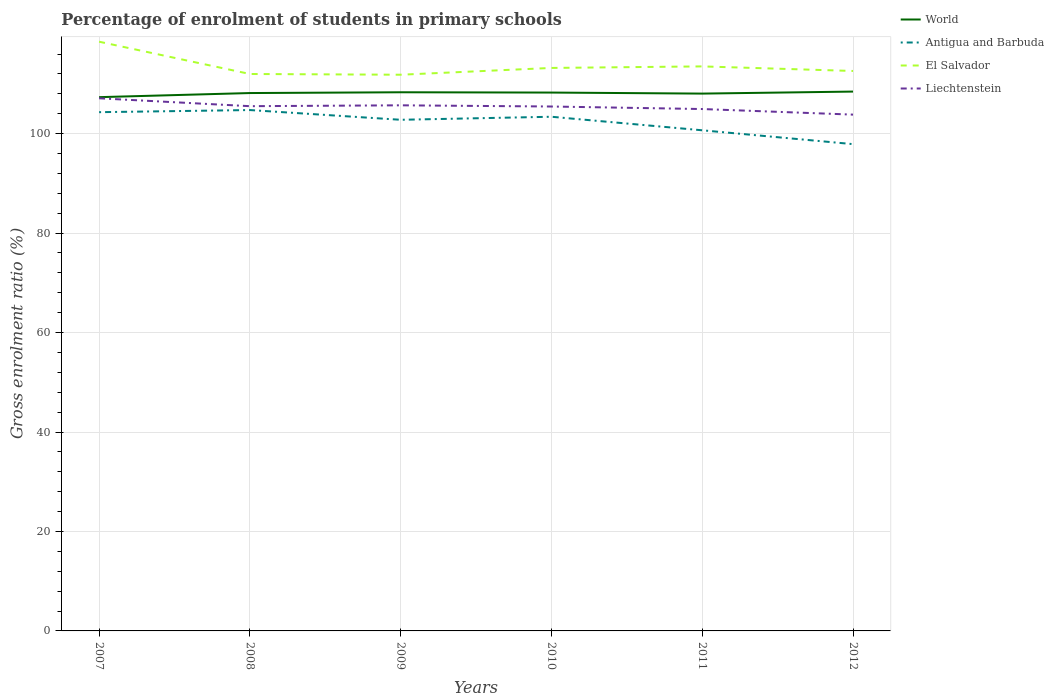Across all years, what is the maximum percentage of students enrolled in primary schools in El Salvador?
Your answer should be compact. 111.85. In which year was the percentage of students enrolled in primary schools in Antigua and Barbuda maximum?
Keep it short and to the point. 2012. What is the total percentage of students enrolled in primary schools in El Salvador in the graph?
Give a very brief answer. -1.37. What is the difference between the highest and the second highest percentage of students enrolled in primary schools in El Salvador?
Keep it short and to the point. 6.64. Is the percentage of students enrolled in primary schools in World strictly greater than the percentage of students enrolled in primary schools in El Salvador over the years?
Your response must be concise. Yes. How many lines are there?
Provide a succinct answer. 4. What is the difference between two consecutive major ticks on the Y-axis?
Your answer should be very brief. 20. Does the graph contain any zero values?
Give a very brief answer. No. Does the graph contain grids?
Offer a terse response. Yes. How are the legend labels stacked?
Provide a short and direct response. Vertical. What is the title of the graph?
Your answer should be very brief. Percentage of enrolment of students in primary schools. Does "North America" appear as one of the legend labels in the graph?
Make the answer very short. No. What is the label or title of the X-axis?
Provide a short and direct response. Years. What is the label or title of the Y-axis?
Give a very brief answer. Gross enrolment ratio (%). What is the Gross enrolment ratio (%) of World in 2007?
Make the answer very short. 107.34. What is the Gross enrolment ratio (%) in Antigua and Barbuda in 2007?
Give a very brief answer. 104.32. What is the Gross enrolment ratio (%) of El Salvador in 2007?
Offer a terse response. 118.49. What is the Gross enrolment ratio (%) of Liechtenstein in 2007?
Offer a very short reply. 107.11. What is the Gross enrolment ratio (%) in World in 2008?
Keep it short and to the point. 108.17. What is the Gross enrolment ratio (%) of Antigua and Barbuda in 2008?
Your answer should be very brief. 104.75. What is the Gross enrolment ratio (%) of El Salvador in 2008?
Provide a succinct answer. 112. What is the Gross enrolment ratio (%) of Liechtenstein in 2008?
Give a very brief answer. 105.53. What is the Gross enrolment ratio (%) in World in 2009?
Offer a terse response. 108.32. What is the Gross enrolment ratio (%) in Antigua and Barbuda in 2009?
Offer a terse response. 102.79. What is the Gross enrolment ratio (%) of El Salvador in 2009?
Ensure brevity in your answer.  111.85. What is the Gross enrolment ratio (%) in Liechtenstein in 2009?
Provide a succinct answer. 105.7. What is the Gross enrolment ratio (%) of World in 2010?
Offer a very short reply. 108.26. What is the Gross enrolment ratio (%) of Antigua and Barbuda in 2010?
Provide a short and direct response. 103.4. What is the Gross enrolment ratio (%) of El Salvador in 2010?
Keep it short and to the point. 113.22. What is the Gross enrolment ratio (%) in Liechtenstein in 2010?
Your answer should be compact. 105.46. What is the Gross enrolment ratio (%) of World in 2011?
Your answer should be very brief. 108.06. What is the Gross enrolment ratio (%) in Antigua and Barbuda in 2011?
Provide a succinct answer. 100.68. What is the Gross enrolment ratio (%) of El Salvador in 2011?
Give a very brief answer. 113.53. What is the Gross enrolment ratio (%) in Liechtenstein in 2011?
Offer a very short reply. 104.95. What is the Gross enrolment ratio (%) in World in 2012?
Keep it short and to the point. 108.46. What is the Gross enrolment ratio (%) in Antigua and Barbuda in 2012?
Ensure brevity in your answer.  97.89. What is the Gross enrolment ratio (%) of El Salvador in 2012?
Make the answer very short. 112.6. What is the Gross enrolment ratio (%) of Liechtenstein in 2012?
Make the answer very short. 103.83. Across all years, what is the maximum Gross enrolment ratio (%) of World?
Your response must be concise. 108.46. Across all years, what is the maximum Gross enrolment ratio (%) in Antigua and Barbuda?
Your response must be concise. 104.75. Across all years, what is the maximum Gross enrolment ratio (%) in El Salvador?
Give a very brief answer. 118.49. Across all years, what is the maximum Gross enrolment ratio (%) in Liechtenstein?
Make the answer very short. 107.11. Across all years, what is the minimum Gross enrolment ratio (%) in World?
Offer a terse response. 107.34. Across all years, what is the minimum Gross enrolment ratio (%) in Antigua and Barbuda?
Your response must be concise. 97.89. Across all years, what is the minimum Gross enrolment ratio (%) in El Salvador?
Your answer should be compact. 111.85. Across all years, what is the minimum Gross enrolment ratio (%) of Liechtenstein?
Give a very brief answer. 103.83. What is the total Gross enrolment ratio (%) in World in the graph?
Provide a short and direct response. 648.61. What is the total Gross enrolment ratio (%) of Antigua and Barbuda in the graph?
Your answer should be very brief. 613.83. What is the total Gross enrolment ratio (%) of El Salvador in the graph?
Offer a terse response. 681.69. What is the total Gross enrolment ratio (%) in Liechtenstein in the graph?
Offer a terse response. 632.57. What is the difference between the Gross enrolment ratio (%) of World in 2007 and that in 2008?
Offer a terse response. -0.83. What is the difference between the Gross enrolment ratio (%) in Antigua and Barbuda in 2007 and that in 2008?
Provide a succinct answer. -0.43. What is the difference between the Gross enrolment ratio (%) of El Salvador in 2007 and that in 2008?
Make the answer very short. 6.49. What is the difference between the Gross enrolment ratio (%) in Liechtenstein in 2007 and that in 2008?
Your answer should be very brief. 1.59. What is the difference between the Gross enrolment ratio (%) of World in 2007 and that in 2009?
Ensure brevity in your answer.  -0.98. What is the difference between the Gross enrolment ratio (%) in Antigua and Barbuda in 2007 and that in 2009?
Your answer should be compact. 1.53. What is the difference between the Gross enrolment ratio (%) of El Salvador in 2007 and that in 2009?
Provide a short and direct response. 6.64. What is the difference between the Gross enrolment ratio (%) in Liechtenstein in 2007 and that in 2009?
Your answer should be compact. 1.41. What is the difference between the Gross enrolment ratio (%) in World in 2007 and that in 2010?
Offer a terse response. -0.92. What is the difference between the Gross enrolment ratio (%) in Antigua and Barbuda in 2007 and that in 2010?
Offer a terse response. 0.92. What is the difference between the Gross enrolment ratio (%) of El Salvador in 2007 and that in 2010?
Offer a very short reply. 5.28. What is the difference between the Gross enrolment ratio (%) in Liechtenstein in 2007 and that in 2010?
Your answer should be compact. 1.65. What is the difference between the Gross enrolment ratio (%) of World in 2007 and that in 2011?
Provide a short and direct response. -0.72. What is the difference between the Gross enrolment ratio (%) in Antigua and Barbuda in 2007 and that in 2011?
Offer a terse response. 3.64. What is the difference between the Gross enrolment ratio (%) of El Salvador in 2007 and that in 2011?
Keep it short and to the point. 4.97. What is the difference between the Gross enrolment ratio (%) in Liechtenstein in 2007 and that in 2011?
Make the answer very short. 2.16. What is the difference between the Gross enrolment ratio (%) of World in 2007 and that in 2012?
Offer a terse response. -1.12. What is the difference between the Gross enrolment ratio (%) in Antigua and Barbuda in 2007 and that in 2012?
Your answer should be compact. 6.43. What is the difference between the Gross enrolment ratio (%) in El Salvador in 2007 and that in 2012?
Offer a terse response. 5.89. What is the difference between the Gross enrolment ratio (%) of Liechtenstein in 2007 and that in 2012?
Make the answer very short. 3.28. What is the difference between the Gross enrolment ratio (%) of World in 2008 and that in 2009?
Make the answer very short. -0.16. What is the difference between the Gross enrolment ratio (%) in Antigua and Barbuda in 2008 and that in 2009?
Make the answer very short. 1.96. What is the difference between the Gross enrolment ratio (%) of El Salvador in 2008 and that in 2009?
Your answer should be compact. 0.15. What is the difference between the Gross enrolment ratio (%) of Liechtenstein in 2008 and that in 2009?
Offer a terse response. -0.17. What is the difference between the Gross enrolment ratio (%) in World in 2008 and that in 2010?
Your answer should be compact. -0.1. What is the difference between the Gross enrolment ratio (%) in Antigua and Barbuda in 2008 and that in 2010?
Offer a very short reply. 1.35. What is the difference between the Gross enrolment ratio (%) in El Salvador in 2008 and that in 2010?
Your answer should be compact. -1.22. What is the difference between the Gross enrolment ratio (%) in Liechtenstein in 2008 and that in 2010?
Give a very brief answer. 0.07. What is the difference between the Gross enrolment ratio (%) of World in 2008 and that in 2011?
Your answer should be very brief. 0.11. What is the difference between the Gross enrolment ratio (%) in Antigua and Barbuda in 2008 and that in 2011?
Keep it short and to the point. 4.07. What is the difference between the Gross enrolment ratio (%) of El Salvador in 2008 and that in 2011?
Provide a succinct answer. -1.53. What is the difference between the Gross enrolment ratio (%) in Liechtenstein in 2008 and that in 2011?
Your answer should be compact. 0.58. What is the difference between the Gross enrolment ratio (%) of World in 2008 and that in 2012?
Your answer should be very brief. -0.29. What is the difference between the Gross enrolment ratio (%) of Antigua and Barbuda in 2008 and that in 2012?
Give a very brief answer. 6.85. What is the difference between the Gross enrolment ratio (%) in El Salvador in 2008 and that in 2012?
Provide a succinct answer. -0.61. What is the difference between the Gross enrolment ratio (%) of Liechtenstein in 2008 and that in 2012?
Ensure brevity in your answer.  1.7. What is the difference between the Gross enrolment ratio (%) in World in 2009 and that in 2010?
Keep it short and to the point. 0.06. What is the difference between the Gross enrolment ratio (%) of Antigua and Barbuda in 2009 and that in 2010?
Provide a short and direct response. -0.61. What is the difference between the Gross enrolment ratio (%) of El Salvador in 2009 and that in 2010?
Your answer should be compact. -1.37. What is the difference between the Gross enrolment ratio (%) in Liechtenstein in 2009 and that in 2010?
Ensure brevity in your answer.  0.24. What is the difference between the Gross enrolment ratio (%) in World in 2009 and that in 2011?
Your answer should be very brief. 0.27. What is the difference between the Gross enrolment ratio (%) of Antigua and Barbuda in 2009 and that in 2011?
Keep it short and to the point. 2.11. What is the difference between the Gross enrolment ratio (%) in El Salvador in 2009 and that in 2011?
Provide a succinct answer. -1.67. What is the difference between the Gross enrolment ratio (%) of Liechtenstein in 2009 and that in 2011?
Give a very brief answer. 0.75. What is the difference between the Gross enrolment ratio (%) of World in 2009 and that in 2012?
Provide a succinct answer. -0.14. What is the difference between the Gross enrolment ratio (%) in Antigua and Barbuda in 2009 and that in 2012?
Your response must be concise. 4.9. What is the difference between the Gross enrolment ratio (%) of El Salvador in 2009 and that in 2012?
Give a very brief answer. -0.75. What is the difference between the Gross enrolment ratio (%) in Liechtenstein in 2009 and that in 2012?
Offer a very short reply. 1.87. What is the difference between the Gross enrolment ratio (%) of World in 2010 and that in 2011?
Provide a short and direct response. 0.21. What is the difference between the Gross enrolment ratio (%) in Antigua and Barbuda in 2010 and that in 2011?
Keep it short and to the point. 2.72. What is the difference between the Gross enrolment ratio (%) of El Salvador in 2010 and that in 2011?
Offer a very short reply. -0.31. What is the difference between the Gross enrolment ratio (%) in Liechtenstein in 2010 and that in 2011?
Offer a very short reply. 0.51. What is the difference between the Gross enrolment ratio (%) in World in 2010 and that in 2012?
Ensure brevity in your answer.  -0.2. What is the difference between the Gross enrolment ratio (%) in Antigua and Barbuda in 2010 and that in 2012?
Give a very brief answer. 5.51. What is the difference between the Gross enrolment ratio (%) of El Salvador in 2010 and that in 2012?
Offer a terse response. 0.61. What is the difference between the Gross enrolment ratio (%) in Liechtenstein in 2010 and that in 2012?
Provide a succinct answer. 1.63. What is the difference between the Gross enrolment ratio (%) in World in 2011 and that in 2012?
Provide a short and direct response. -0.4. What is the difference between the Gross enrolment ratio (%) of Antigua and Barbuda in 2011 and that in 2012?
Provide a succinct answer. 2.78. What is the difference between the Gross enrolment ratio (%) of El Salvador in 2011 and that in 2012?
Offer a terse response. 0.92. What is the difference between the Gross enrolment ratio (%) in Liechtenstein in 2011 and that in 2012?
Provide a succinct answer. 1.12. What is the difference between the Gross enrolment ratio (%) in World in 2007 and the Gross enrolment ratio (%) in Antigua and Barbuda in 2008?
Your response must be concise. 2.59. What is the difference between the Gross enrolment ratio (%) in World in 2007 and the Gross enrolment ratio (%) in El Salvador in 2008?
Give a very brief answer. -4.66. What is the difference between the Gross enrolment ratio (%) in World in 2007 and the Gross enrolment ratio (%) in Liechtenstein in 2008?
Provide a short and direct response. 1.81. What is the difference between the Gross enrolment ratio (%) of Antigua and Barbuda in 2007 and the Gross enrolment ratio (%) of El Salvador in 2008?
Make the answer very short. -7.68. What is the difference between the Gross enrolment ratio (%) in Antigua and Barbuda in 2007 and the Gross enrolment ratio (%) in Liechtenstein in 2008?
Ensure brevity in your answer.  -1.21. What is the difference between the Gross enrolment ratio (%) of El Salvador in 2007 and the Gross enrolment ratio (%) of Liechtenstein in 2008?
Your answer should be very brief. 12.97. What is the difference between the Gross enrolment ratio (%) in World in 2007 and the Gross enrolment ratio (%) in Antigua and Barbuda in 2009?
Make the answer very short. 4.55. What is the difference between the Gross enrolment ratio (%) in World in 2007 and the Gross enrolment ratio (%) in El Salvador in 2009?
Ensure brevity in your answer.  -4.51. What is the difference between the Gross enrolment ratio (%) of World in 2007 and the Gross enrolment ratio (%) of Liechtenstein in 2009?
Provide a succinct answer. 1.64. What is the difference between the Gross enrolment ratio (%) in Antigua and Barbuda in 2007 and the Gross enrolment ratio (%) in El Salvador in 2009?
Your answer should be very brief. -7.53. What is the difference between the Gross enrolment ratio (%) in Antigua and Barbuda in 2007 and the Gross enrolment ratio (%) in Liechtenstein in 2009?
Provide a succinct answer. -1.38. What is the difference between the Gross enrolment ratio (%) of El Salvador in 2007 and the Gross enrolment ratio (%) of Liechtenstein in 2009?
Your answer should be very brief. 12.79. What is the difference between the Gross enrolment ratio (%) of World in 2007 and the Gross enrolment ratio (%) of Antigua and Barbuda in 2010?
Give a very brief answer. 3.94. What is the difference between the Gross enrolment ratio (%) in World in 2007 and the Gross enrolment ratio (%) in El Salvador in 2010?
Your answer should be very brief. -5.88. What is the difference between the Gross enrolment ratio (%) in World in 2007 and the Gross enrolment ratio (%) in Liechtenstein in 2010?
Offer a very short reply. 1.88. What is the difference between the Gross enrolment ratio (%) in Antigua and Barbuda in 2007 and the Gross enrolment ratio (%) in El Salvador in 2010?
Ensure brevity in your answer.  -8.9. What is the difference between the Gross enrolment ratio (%) of Antigua and Barbuda in 2007 and the Gross enrolment ratio (%) of Liechtenstein in 2010?
Your response must be concise. -1.14. What is the difference between the Gross enrolment ratio (%) of El Salvador in 2007 and the Gross enrolment ratio (%) of Liechtenstein in 2010?
Keep it short and to the point. 13.03. What is the difference between the Gross enrolment ratio (%) in World in 2007 and the Gross enrolment ratio (%) in Antigua and Barbuda in 2011?
Your response must be concise. 6.66. What is the difference between the Gross enrolment ratio (%) of World in 2007 and the Gross enrolment ratio (%) of El Salvador in 2011?
Provide a short and direct response. -6.19. What is the difference between the Gross enrolment ratio (%) of World in 2007 and the Gross enrolment ratio (%) of Liechtenstein in 2011?
Your response must be concise. 2.39. What is the difference between the Gross enrolment ratio (%) in Antigua and Barbuda in 2007 and the Gross enrolment ratio (%) in El Salvador in 2011?
Ensure brevity in your answer.  -9.21. What is the difference between the Gross enrolment ratio (%) of Antigua and Barbuda in 2007 and the Gross enrolment ratio (%) of Liechtenstein in 2011?
Your response must be concise. -0.63. What is the difference between the Gross enrolment ratio (%) in El Salvador in 2007 and the Gross enrolment ratio (%) in Liechtenstein in 2011?
Ensure brevity in your answer.  13.54. What is the difference between the Gross enrolment ratio (%) of World in 2007 and the Gross enrolment ratio (%) of Antigua and Barbuda in 2012?
Your answer should be very brief. 9.45. What is the difference between the Gross enrolment ratio (%) of World in 2007 and the Gross enrolment ratio (%) of El Salvador in 2012?
Make the answer very short. -5.26. What is the difference between the Gross enrolment ratio (%) in World in 2007 and the Gross enrolment ratio (%) in Liechtenstein in 2012?
Your answer should be compact. 3.51. What is the difference between the Gross enrolment ratio (%) of Antigua and Barbuda in 2007 and the Gross enrolment ratio (%) of El Salvador in 2012?
Provide a succinct answer. -8.29. What is the difference between the Gross enrolment ratio (%) of Antigua and Barbuda in 2007 and the Gross enrolment ratio (%) of Liechtenstein in 2012?
Keep it short and to the point. 0.49. What is the difference between the Gross enrolment ratio (%) of El Salvador in 2007 and the Gross enrolment ratio (%) of Liechtenstein in 2012?
Make the answer very short. 14.66. What is the difference between the Gross enrolment ratio (%) in World in 2008 and the Gross enrolment ratio (%) in Antigua and Barbuda in 2009?
Keep it short and to the point. 5.38. What is the difference between the Gross enrolment ratio (%) of World in 2008 and the Gross enrolment ratio (%) of El Salvador in 2009?
Your response must be concise. -3.68. What is the difference between the Gross enrolment ratio (%) of World in 2008 and the Gross enrolment ratio (%) of Liechtenstein in 2009?
Your response must be concise. 2.47. What is the difference between the Gross enrolment ratio (%) of Antigua and Barbuda in 2008 and the Gross enrolment ratio (%) of El Salvador in 2009?
Your response must be concise. -7.1. What is the difference between the Gross enrolment ratio (%) of Antigua and Barbuda in 2008 and the Gross enrolment ratio (%) of Liechtenstein in 2009?
Your answer should be compact. -0.95. What is the difference between the Gross enrolment ratio (%) of El Salvador in 2008 and the Gross enrolment ratio (%) of Liechtenstein in 2009?
Your answer should be very brief. 6.3. What is the difference between the Gross enrolment ratio (%) in World in 2008 and the Gross enrolment ratio (%) in Antigua and Barbuda in 2010?
Provide a short and direct response. 4.77. What is the difference between the Gross enrolment ratio (%) in World in 2008 and the Gross enrolment ratio (%) in El Salvador in 2010?
Your answer should be compact. -5.05. What is the difference between the Gross enrolment ratio (%) in World in 2008 and the Gross enrolment ratio (%) in Liechtenstein in 2010?
Your answer should be very brief. 2.71. What is the difference between the Gross enrolment ratio (%) of Antigua and Barbuda in 2008 and the Gross enrolment ratio (%) of El Salvador in 2010?
Your response must be concise. -8.47. What is the difference between the Gross enrolment ratio (%) in Antigua and Barbuda in 2008 and the Gross enrolment ratio (%) in Liechtenstein in 2010?
Offer a terse response. -0.71. What is the difference between the Gross enrolment ratio (%) in El Salvador in 2008 and the Gross enrolment ratio (%) in Liechtenstein in 2010?
Your answer should be compact. 6.54. What is the difference between the Gross enrolment ratio (%) of World in 2008 and the Gross enrolment ratio (%) of Antigua and Barbuda in 2011?
Give a very brief answer. 7.49. What is the difference between the Gross enrolment ratio (%) of World in 2008 and the Gross enrolment ratio (%) of El Salvador in 2011?
Your response must be concise. -5.36. What is the difference between the Gross enrolment ratio (%) of World in 2008 and the Gross enrolment ratio (%) of Liechtenstein in 2011?
Provide a succinct answer. 3.22. What is the difference between the Gross enrolment ratio (%) in Antigua and Barbuda in 2008 and the Gross enrolment ratio (%) in El Salvador in 2011?
Offer a terse response. -8.78. What is the difference between the Gross enrolment ratio (%) in Antigua and Barbuda in 2008 and the Gross enrolment ratio (%) in Liechtenstein in 2011?
Provide a succinct answer. -0.2. What is the difference between the Gross enrolment ratio (%) of El Salvador in 2008 and the Gross enrolment ratio (%) of Liechtenstein in 2011?
Provide a short and direct response. 7.05. What is the difference between the Gross enrolment ratio (%) of World in 2008 and the Gross enrolment ratio (%) of Antigua and Barbuda in 2012?
Offer a very short reply. 10.27. What is the difference between the Gross enrolment ratio (%) of World in 2008 and the Gross enrolment ratio (%) of El Salvador in 2012?
Offer a very short reply. -4.44. What is the difference between the Gross enrolment ratio (%) in World in 2008 and the Gross enrolment ratio (%) in Liechtenstein in 2012?
Offer a very short reply. 4.34. What is the difference between the Gross enrolment ratio (%) in Antigua and Barbuda in 2008 and the Gross enrolment ratio (%) in El Salvador in 2012?
Offer a terse response. -7.86. What is the difference between the Gross enrolment ratio (%) of Antigua and Barbuda in 2008 and the Gross enrolment ratio (%) of Liechtenstein in 2012?
Offer a very short reply. 0.92. What is the difference between the Gross enrolment ratio (%) of El Salvador in 2008 and the Gross enrolment ratio (%) of Liechtenstein in 2012?
Make the answer very short. 8.17. What is the difference between the Gross enrolment ratio (%) of World in 2009 and the Gross enrolment ratio (%) of Antigua and Barbuda in 2010?
Make the answer very short. 4.92. What is the difference between the Gross enrolment ratio (%) of World in 2009 and the Gross enrolment ratio (%) of El Salvador in 2010?
Make the answer very short. -4.89. What is the difference between the Gross enrolment ratio (%) in World in 2009 and the Gross enrolment ratio (%) in Liechtenstein in 2010?
Provide a succinct answer. 2.86. What is the difference between the Gross enrolment ratio (%) in Antigua and Barbuda in 2009 and the Gross enrolment ratio (%) in El Salvador in 2010?
Provide a succinct answer. -10.43. What is the difference between the Gross enrolment ratio (%) of Antigua and Barbuda in 2009 and the Gross enrolment ratio (%) of Liechtenstein in 2010?
Provide a short and direct response. -2.67. What is the difference between the Gross enrolment ratio (%) of El Salvador in 2009 and the Gross enrolment ratio (%) of Liechtenstein in 2010?
Ensure brevity in your answer.  6.39. What is the difference between the Gross enrolment ratio (%) in World in 2009 and the Gross enrolment ratio (%) in Antigua and Barbuda in 2011?
Provide a short and direct response. 7.65. What is the difference between the Gross enrolment ratio (%) of World in 2009 and the Gross enrolment ratio (%) of El Salvador in 2011?
Your answer should be compact. -5.2. What is the difference between the Gross enrolment ratio (%) in World in 2009 and the Gross enrolment ratio (%) in Liechtenstein in 2011?
Your response must be concise. 3.37. What is the difference between the Gross enrolment ratio (%) of Antigua and Barbuda in 2009 and the Gross enrolment ratio (%) of El Salvador in 2011?
Make the answer very short. -10.74. What is the difference between the Gross enrolment ratio (%) in Antigua and Barbuda in 2009 and the Gross enrolment ratio (%) in Liechtenstein in 2011?
Ensure brevity in your answer.  -2.16. What is the difference between the Gross enrolment ratio (%) in El Salvador in 2009 and the Gross enrolment ratio (%) in Liechtenstein in 2011?
Keep it short and to the point. 6.9. What is the difference between the Gross enrolment ratio (%) in World in 2009 and the Gross enrolment ratio (%) in Antigua and Barbuda in 2012?
Offer a terse response. 10.43. What is the difference between the Gross enrolment ratio (%) in World in 2009 and the Gross enrolment ratio (%) in El Salvador in 2012?
Provide a succinct answer. -4.28. What is the difference between the Gross enrolment ratio (%) in World in 2009 and the Gross enrolment ratio (%) in Liechtenstein in 2012?
Offer a terse response. 4.5. What is the difference between the Gross enrolment ratio (%) of Antigua and Barbuda in 2009 and the Gross enrolment ratio (%) of El Salvador in 2012?
Make the answer very short. -9.82. What is the difference between the Gross enrolment ratio (%) of Antigua and Barbuda in 2009 and the Gross enrolment ratio (%) of Liechtenstein in 2012?
Provide a succinct answer. -1.04. What is the difference between the Gross enrolment ratio (%) in El Salvador in 2009 and the Gross enrolment ratio (%) in Liechtenstein in 2012?
Make the answer very short. 8.02. What is the difference between the Gross enrolment ratio (%) in World in 2010 and the Gross enrolment ratio (%) in Antigua and Barbuda in 2011?
Your response must be concise. 7.59. What is the difference between the Gross enrolment ratio (%) in World in 2010 and the Gross enrolment ratio (%) in El Salvador in 2011?
Provide a succinct answer. -5.26. What is the difference between the Gross enrolment ratio (%) of World in 2010 and the Gross enrolment ratio (%) of Liechtenstein in 2011?
Give a very brief answer. 3.31. What is the difference between the Gross enrolment ratio (%) in Antigua and Barbuda in 2010 and the Gross enrolment ratio (%) in El Salvador in 2011?
Ensure brevity in your answer.  -10.13. What is the difference between the Gross enrolment ratio (%) of Antigua and Barbuda in 2010 and the Gross enrolment ratio (%) of Liechtenstein in 2011?
Offer a terse response. -1.55. What is the difference between the Gross enrolment ratio (%) of El Salvador in 2010 and the Gross enrolment ratio (%) of Liechtenstein in 2011?
Keep it short and to the point. 8.27. What is the difference between the Gross enrolment ratio (%) in World in 2010 and the Gross enrolment ratio (%) in Antigua and Barbuda in 2012?
Keep it short and to the point. 10.37. What is the difference between the Gross enrolment ratio (%) in World in 2010 and the Gross enrolment ratio (%) in El Salvador in 2012?
Provide a short and direct response. -4.34. What is the difference between the Gross enrolment ratio (%) in World in 2010 and the Gross enrolment ratio (%) in Liechtenstein in 2012?
Your answer should be compact. 4.44. What is the difference between the Gross enrolment ratio (%) of Antigua and Barbuda in 2010 and the Gross enrolment ratio (%) of El Salvador in 2012?
Offer a terse response. -9.21. What is the difference between the Gross enrolment ratio (%) of Antigua and Barbuda in 2010 and the Gross enrolment ratio (%) of Liechtenstein in 2012?
Provide a short and direct response. -0.43. What is the difference between the Gross enrolment ratio (%) in El Salvador in 2010 and the Gross enrolment ratio (%) in Liechtenstein in 2012?
Provide a succinct answer. 9.39. What is the difference between the Gross enrolment ratio (%) of World in 2011 and the Gross enrolment ratio (%) of Antigua and Barbuda in 2012?
Your response must be concise. 10.16. What is the difference between the Gross enrolment ratio (%) in World in 2011 and the Gross enrolment ratio (%) in El Salvador in 2012?
Keep it short and to the point. -4.55. What is the difference between the Gross enrolment ratio (%) of World in 2011 and the Gross enrolment ratio (%) of Liechtenstein in 2012?
Your answer should be very brief. 4.23. What is the difference between the Gross enrolment ratio (%) in Antigua and Barbuda in 2011 and the Gross enrolment ratio (%) in El Salvador in 2012?
Provide a succinct answer. -11.93. What is the difference between the Gross enrolment ratio (%) in Antigua and Barbuda in 2011 and the Gross enrolment ratio (%) in Liechtenstein in 2012?
Your answer should be very brief. -3.15. What is the difference between the Gross enrolment ratio (%) of El Salvador in 2011 and the Gross enrolment ratio (%) of Liechtenstein in 2012?
Provide a succinct answer. 9.7. What is the average Gross enrolment ratio (%) in World per year?
Your response must be concise. 108.1. What is the average Gross enrolment ratio (%) in Antigua and Barbuda per year?
Your answer should be very brief. 102.3. What is the average Gross enrolment ratio (%) of El Salvador per year?
Give a very brief answer. 113.62. What is the average Gross enrolment ratio (%) of Liechtenstein per year?
Keep it short and to the point. 105.43. In the year 2007, what is the difference between the Gross enrolment ratio (%) of World and Gross enrolment ratio (%) of Antigua and Barbuda?
Keep it short and to the point. 3.02. In the year 2007, what is the difference between the Gross enrolment ratio (%) in World and Gross enrolment ratio (%) in El Salvador?
Provide a succinct answer. -11.15. In the year 2007, what is the difference between the Gross enrolment ratio (%) of World and Gross enrolment ratio (%) of Liechtenstein?
Provide a short and direct response. 0.23. In the year 2007, what is the difference between the Gross enrolment ratio (%) in Antigua and Barbuda and Gross enrolment ratio (%) in El Salvador?
Your answer should be compact. -14.17. In the year 2007, what is the difference between the Gross enrolment ratio (%) in Antigua and Barbuda and Gross enrolment ratio (%) in Liechtenstein?
Your answer should be very brief. -2.79. In the year 2007, what is the difference between the Gross enrolment ratio (%) in El Salvador and Gross enrolment ratio (%) in Liechtenstein?
Keep it short and to the point. 11.38. In the year 2008, what is the difference between the Gross enrolment ratio (%) of World and Gross enrolment ratio (%) of Antigua and Barbuda?
Ensure brevity in your answer.  3.42. In the year 2008, what is the difference between the Gross enrolment ratio (%) of World and Gross enrolment ratio (%) of El Salvador?
Offer a terse response. -3.83. In the year 2008, what is the difference between the Gross enrolment ratio (%) in World and Gross enrolment ratio (%) in Liechtenstein?
Make the answer very short. 2.64. In the year 2008, what is the difference between the Gross enrolment ratio (%) of Antigua and Barbuda and Gross enrolment ratio (%) of El Salvador?
Ensure brevity in your answer.  -7.25. In the year 2008, what is the difference between the Gross enrolment ratio (%) of Antigua and Barbuda and Gross enrolment ratio (%) of Liechtenstein?
Ensure brevity in your answer.  -0.78. In the year 2008, what is the difference between the Gross enrolment ratio (%) of El Salvador and Gross enrolment ratio (%) of Liechtenstein?
Offer a terse response. 6.47. In the year 2009, what is the difference between the Gross enrolment ratio (%) of World and Gross enrolment ratio (%) of Antigua and Barbuda?
Offer a very short reply. 5.53. In the year 2009, what is the difference between the Gross enrolment ratio (%) in World and Gross enrolment ratio (%) in El Salvador?
Provide a succinct answer. -3.53. In the year 2009, what is the difference between the Gross enrolment ratio (%) in World and Gross enrolment ratio (%) in Liechtenstein?
Your answer should be very brief. 2.63. In the year 2009, what is the difference between the Gross enrolment ratio (%) in Antigua and Barbuda and Gross enrolment ratio (%) in El Salvador?
Your answer should be very brief. -9.06. In the year 2009, what is the difference between the Gross enrolment ratio (%) of Antigua and Barbuda and Gross enrolment ratio (%) of Liechtenstein?
Give a very brief answer. -2.91. In the year 2009, what is the difference between the Gross enrolment ratio (%) in El Salvador and Gross enrolment ratio (%) in Liechtenstein?
Provide a succinct answer. 6.15. In the year 2010, what is the difference between the Gross enrolment ratio (%) of World and Gross enrolment ratio (%) of Antigua and Barbuda?
Your response must be concise. 4.86. In the year 2010, what is the difference between the Gross enrolment ratio (%) in World and Gross enrolment ratio (%) in El Salvador?
Make the answer very short. -4.95. In the year 2010, what is the difference between the Gross enrolment ratio (%) of World and Gross enrolment ratio (%) of Liechtenstein?
Ensure brevity in your answer.  2.81. In the year 2010, what is the difference between the Gross enrolment ratio (%) of Antigua and Barbuda and Gross enrolment ratio (%) of El Salvador?
Provide a short and direct response. -9.82. In the year 2010, what is the difference between the Gross enrolment ratio (%) in Antigua and Barbuda and Gross enrolment ratio (%) in Liechtenstein?
Provide a succinct answer. -2.06. In the year 2010, what is the difference between the Gross enrolment ratio (%) of El Salvador and Gross enrolment ratio (%) of Liechtenstein?
Your answer should be compact. 7.76. In the year 2011, what is the difference between the Gross enrolment ratio (%) in World and Gross enrolment ratio (%) in Antigua and Barbuda?
Provide a short and direct response. 7.38. In the year 2011, what is the difference between the Gross enrolment ratio (%) of World and Gross enrolment ratio (%) of El Salvador?
Make the answer very short. -5.47. In the year 2011, what is the difference between the Gross enrolment ratio (%) of World and Gross enrolment ratio (%) of Liechtenstein?
Keep it short and to the point. 3.11. In the year 2011, what is the difference between the Gross enrolment ratio (%) in Antigua and Barbuda and Gross enrolment ratio (%) in El Salvador?
Keep it short and to the point. -12.85. In the year 2011, what is the difference between the Gross enrolment ratio (%) in Antigua and Barbuda and Gross enrolment ratio (%) in Liechtenstein?
Your answer should be compact. -4.27. In the year 2011, what is the difference between the Gross enrolment ratio (%) in El Salvador and Gross enrolment ratio (%) in Liechtenstein?
Provide a short and direct response. 8.58. In the year 2012, what is the difference between the Gross enrolment ratio (%) of World and Gross enrolment ratio (%) of Antigua and Barbuda?
Provide a short and direct response. 10.57. In the year 2012, what is the difference between the Gross enrolment ratio (%) of World and Gross enrolment ratio (%) of El Salvador?
Your answer should be compact. -4.14. In the year 2012, what is the difference between the Gross enrolment ratio (%) of World and Gross enrolment ratio (%) of Liechtenstein?
Keep it short and to the point. 4.63. In the year 2012, what is the difference between the Gross enrolment ratio (%) in Antigua and Barbuda and Gross enrolment ratio (%) in El Salvador?
Offer a very short reply. -14.71. In the year 2012, what is the difference between the Gross enrolment ratio (%) of Antigua and Barbuda and Gross enrolment ratio (%) of Liechtenstein?
Give a very brief answer. -5.94. In the year 2012, what is the difference between the Gross enrolment ratio (%) in El Salvador and Gross enrolment ratio (%) in Liechtenstein?
Keep it short and to the point. 8.78. What is the ratio of the Gross enrolment ratio (%) of World in 2007 to that in 2008?
Offer a very short reply. 0.99. What is the ratio of the Gross enrolment ratio (%) of El Salvador in 2007 to that in 2008?
Provide a succinct answer. 1.06. What is the ratio of the Gross enrolment ratio (%) in World in 2007 to that in 2009?
Ensure brevity in your answer.  0.99. What is the ratio of the Gross enrolment ratio (%) of Antigua and Barbuda in 2007 to that in 2009?
Provide a succinct answer. 1.01. What is the ratio of the Gross enrolment ratio (%) of El Salvador in 2007 to that in 2009?
Provide a succinct answer. 1.06. What is the ratio of the Gross enrolment ratio (%) in Liechtenstein in 2007 to that in 2009?
Your answer should be very brief. 1.01. What is the ratio of the Gross enrolment ratio (%) in World in 2007 to that in 2010?
Make the answer very short. 0.99. What is the ratio of the Gross enrolment ratio (%) in Antigua and Barbuda in 2007 to that in 2010?
Provide a short and direct response. 1.01. What is the ratio of the Gross enrolment ratio (%) of El Salvador in 2007 to that in 2010?
Your answer should be compact. 1.05. What is the ratio of the Gross enrolment ratio (%) in Liechtenstein in 2007 to that in 2010?
Your answer should be very brief. 1.02. What is the ratio of the Gross enrolment ratio (%) in World in 2007 to that in 2011?
Keep it short and to the point. 0.99. What is the ratio of the Gross enrolment ratio (%) in Antigua and Barbuda in 2007 to that in 2011?
Provide a succinct answer. 1.04. What is the ratio of the Gross enrolment ratio (%) in El Salvador in 2007 to that in 2011?
Your answer should be compact. 1.04. What is the ratio of the Gross enrolment ratio (%) in Liechtenstein in 2007 to that in 2011?
Your answer should be very brief. 1.02. What is the ratio of the Gross enrolment ratio (%) in Antigua and Barbuda in 2007 to that in 2012?
Offer a very short reply. 1.07. What is the ratio of the Gross enrolment ratio (%) of El Salvador in 2007 to that in 2012?
Your response must be concise. 1.05. What is the ratio of the Gross enrolment ratio (%) of Liechtenstein in 2007 to that in 2012?
Make the answer very short. 1.03. What is the ratio of the Gross enrolment ratio (%) in World in 2008 to that in 2009?
Your answer should be compact. 1. What is the ratio of the Gross enrolment ratio (%) in Antigua and Barbuda in 2008 to that in 2009?
Your answer should be very brief. 1.02. What is the ratio of the Gross enrolment ratio (%) in El Salvador in 2008 to that in 2009?
Provide a succinct answer. 1. What is the ratio of the Gross enrolment ratio (%) of Liechtenstein in 2008 to that in 2009?
Make the answer very short. 1. What is the ratio of the Gross enrolment ratio (%) in World in 2008 to that in 2010?
Ensure brevity in your answer.  1. What is the ratio of the Gross enrolment ratio (%) in Antigua and Barbuda in 2008 to that in 2010?
Provide a short and direct response. 1.01. What is the ratio of the Gross enrolment ratio (%) in El Salvador in 2008 to that in 2010?
Offer a very short reply. 0.99. What is the ratio of the Gross enrolment ratio (%) in Liechtenstein in 2008 to that in 2010?
Keep it short and to the point. 1. What is the ratio of the Gross enrolment ratio (%) of World in 2008 to that in 2011?
Make the answer very short. 1. What is the ratio of the Gross enrolment ratio (%) in Antigua and Barbuda in 2008 to that in 2011?
Ensure brevity in your answer.  1.04. What is the ratio of the Gross enrolment ratio (%) of El Salvador in 2008 to that in 2011?
Provide a short and direct response. 0.99. What is the ratio of the Gross enrolment ratio (%) of World in 2008 to that in 2012?
Your response must be concise. 1. What is the ratio of the Gross enrolment ratio (%) of Antigua and Barbuda in 2008 to that in 2012?
Keep it short and to the point. 1.07. What is the ratio of the Gross enrolment ratio (%) in El Salvador in 2008 to that in 2012?
Your answer should be compact. 0.99. What is the ratio of the Gross enrolment ratio (%) of Liechtenstein in 2008 to that in 2012?
Make the answer very short. 1.02. What is the ratio of the Gross enrolment ratio (%) in World in 2009 to that in 2010?
Your response must be concise. 1. What is the ratio of the Gross enrolment ratio (%) of El Salvador in 2009 to that in 2010?
Ensure brevity in your answer.  0.99. What is the ratio of the Gross enrolment ratio (%) in Liechtenstein in 2009 to that in 2011?
Offer a very short reply. 1.01. What is the ratio of the Gross enrolment ratio (%) in World in 2009 to that in 2012?
Keep it short and to the point. 1. What is the ratio of the Gross enrolment ratio (%) of Antigua and Barbuda in 2009 to that in 2012?
Your answer should be compact. 1.05. What is the ratio of the Gross enrolment ratio (%) of Liechtenstein in 2009 to that in 2012?
Make the answer very short. 1.02. What is the ratio of the Gross enrolment ratio (%) of World in 2010 to that in 2011?
Offer a terse response. 1. What is the ratio of the Gross enrolment ratio (%) in Liechtenstein in 2010 to that in 2011?
Offer a terse response. 1. What is the ratio of the Gross enrolment ratio (%) in Antigua and Barbuda in 2010 to that in 2012?
Your answer should be very brief. 1.06. What is the ratio of the Gross enrolment ratio (%) in El Salvador in 2010 to that in 2012?
Your answer should be compact. 1.01. What is the ratio of the Gross enrolment ratio (%) in Liechtenstein in 2010 to that in 2012?
Make the answer very short. 1.02. What is the ratio of the Gross enrolment ratio (%) in Antigua and Barbuda in 2011 to that in 2012?
Offer a terse response. 1.03. What is the ratio of the Gross enrolment ratio (%) of El Salvador in 2011 to that in 2012?
Provide a short and direct response. 1.01. What is the ratio of the Gross enrolment ratio (%) of Liechtenstein in 2011 to that in 2012?
Keep it short and to the point. 1.01. What is the difference between the highest and the second highest Gross enrolment ratio (%) in World?
Your response must be concise. 0.14. What is the difference between the highest and the second highest Gross enrolment ratio (%) in Antigua and Barbuda?
Your answer should be compact. 0.43. What is the difference between the highest and the second highest Gross enrolment ratio (%) of El Salvador?
Give a very brief answer. 4.97. What is the difference between the highest and the second highest Gross enrolment ratio (%) in Liechtenstein?
Your answer should be very brief. 1.41. What is the difference between the highest and the lowest Gross enrolment ratio (%) of World?
Your response must be concise. 1.12. What is the difference between the highest and the lowest Gross enrolment ratio (%) in Antigua and Barbuda?
Your answer should be very brief. 6.85. What is the difference between the highest and the lowest Gross enrolment ratio (%) of El Salvador?
Your answer should be compact. 6.64. What is the difference between the highest and the lowest Gross enrolment ratio (%) in Liechtenstein?
Your answer should be very brief. 3.28. 